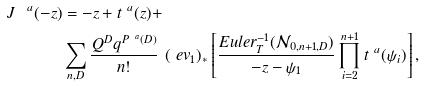Convert formula to latex. <formula><loc_0><loc_0><loc_500><loc_500>\ J ^ { \ a } ( - z ) & = - z + t ^ { \ a } ( z ) + \\ & \sum _ { n , D } \frac { Q ^ { D } q ^ { P ^ { \ a } ( D ) } } { n ! } \ ( \ e v _ { 1 } ) _ { * } \left [ \frac { E u l e r _ { T } ^ { - 1 } ( { \mathcal { N } } _ { 0 , n + 1 , D } ) } { - z - \psi _ { 1 } } \prod _ { i = 2 } ^ { n + 1 } t ^ { \ a } ( \psi _ { i } ) \right ] ,</formula> 